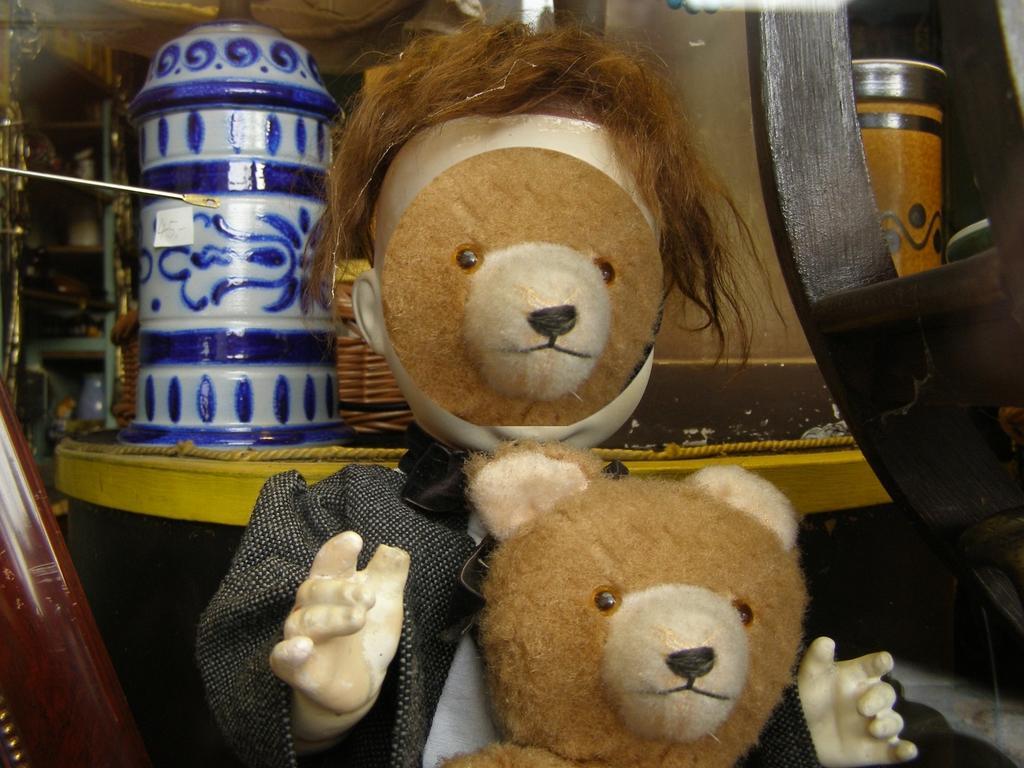Describe this image in one or two sentences. Front we can see two teddies. Background there is a rope, basket and things. 